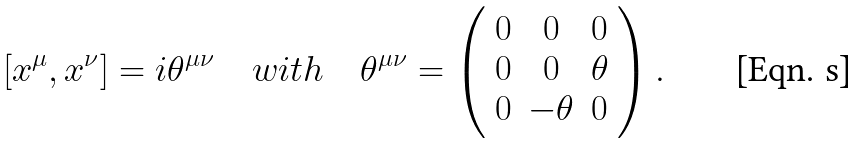<formula> <loc_0><loc_0><loc_500><loc_500>[ x ^ { \mu } , x ^ { \nu } ] = i \theta ^ { \mu \nu } \quad w i t h \quad \theta ^ { \mu \nu } = \left ( \begin{array} { c c c } { 0 } & { 0 } & { 0 } \\ { 0 } & { 0 } & { \theta } \\ { 0 } & { - \theta } & { 0 } \end{array} \right ) .</formula> 